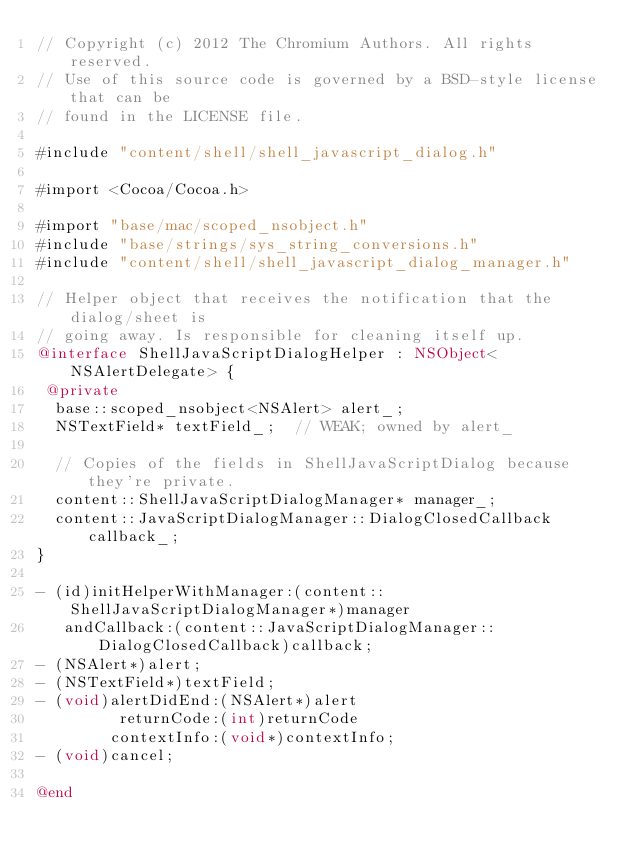<code> <loc_0><loc_0><loc_500><loc_500><_ObjectiveC_>// Copyright (c) 2012 The Chromium Authors. All rights reserved.
// Use of this source code is governed by a BSD-style license that can be
// found in the LICENSE file.

#include "content/shell/shell_javascript_dialog.h"

#import <Cocoa/Cocoa.h>

#import "base/mac/scoped_nsobject.h"
#include "base/strings/sys_string_conversions.h"
#include "content/shell/shell_javascript_dialog_manager.h"

// Helper object that receives the notification that the dialog/sheet is
// going away. Is responsible for cleaning itself up.
@interface ShellJavaScriptDialogHelper : NSObject<NSAlertDelegate> {
 @private
  base::scoped_nsobject<NSAlert> alert_;
  NSTextField* textField_;  // WEAK; owned by alert_

  // Copies of the fields in ShellJavaScriptDialog because they're private.
  content::ShellJavaScriptDialogManager* manager_;
  content::JavaScriptDialogManager::DialogClosedCallback callback_;
}

- (id)initHelperWithManager:(content::ShellJavaScriptDialogManager*)manager
   andCallback:(content::JavaScriptDialogManager::DialogClosedCallback)callback;
- (NSAlert*)alert;
- (NSTextField*)textField;
- (void)alertDidEnd:(NSAlert*)alert
         returnCode:(int)returnCode
        contextInfo:(void*)contextInfo;
- (void)cancel;

@end
</code> 